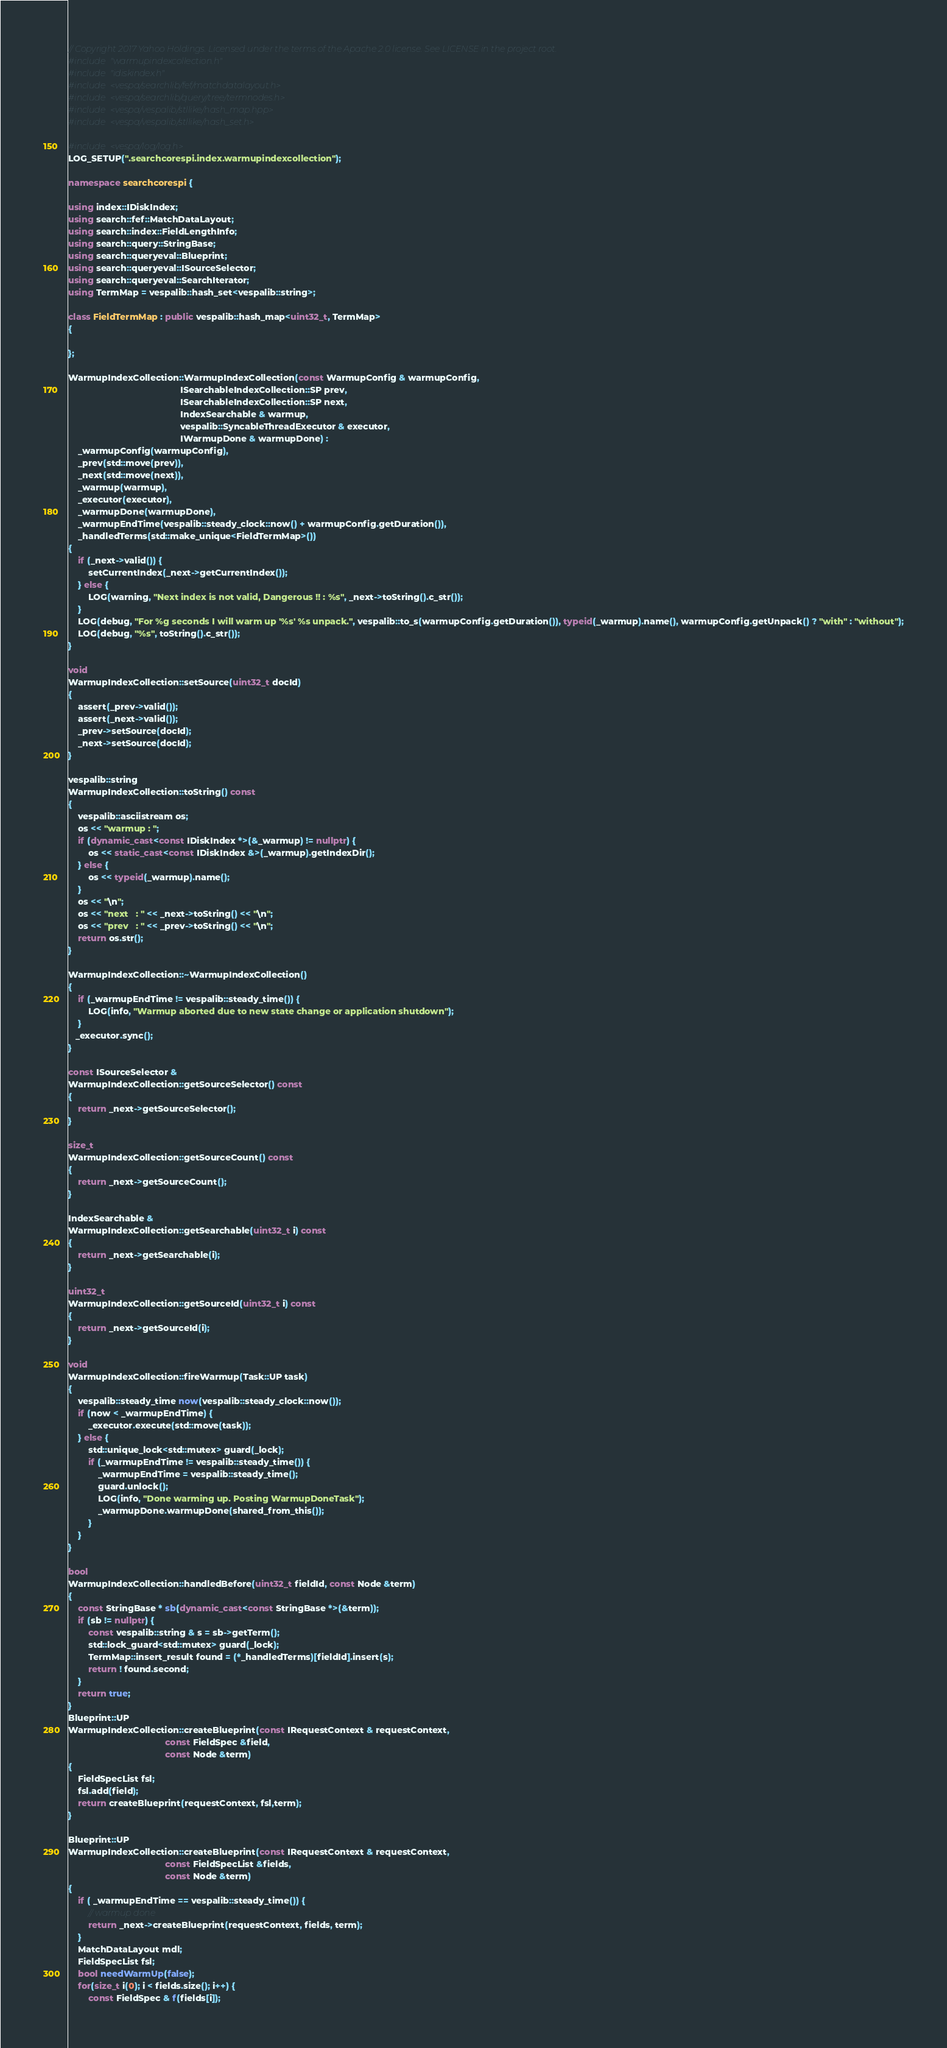Convert code to text. <code><loc_0><loc_0><loc_500><loc_500><_C++_>// Copyright 2017 Yahoo Holdings. Licensed under the terms of the Apache 2.0 license. See LICENSE in the project root.
#include "warmupindexcollection.h"
#include "idiskindex.h"
#include <vespa/searchlib/fef/matchdatalayout.h>
#include <vespa/searchlib/query/tree/termnodes.h>
#include <vespa/vespalib/stllike/hash_map.hpp>
#include <vespa/vespalib/stllike/hash_set.h>

#include <vespa/log/log.h>
LOG_SETUP(".searchcorespi.index.warmupindexcollection");

namespace searchcorespi {

using index::IDiskIndex;
using search::fef::MatchDataLayout;
using search::index::FieldLengthInfo;
using search::query::StringBase;
using search::queryeval::Blueprint;
using search::queryeval::ISourceSelector;
using search::queryeval::SearchIterator;
using TermMap = vespalib::hash_set<vespalib::string>;

class FieldTermMap : public vespalib::hash_map<uint32_t, TermMap>
{

};

WarmupIndexCollection::WarmupIndexCollection(const WarmupConfig & warmupConfig,
                                             ISearchableIndexCollection::SP prev,
                                             ISearchableIndexCollection::SP next,
                                             IndexSearchable & warmup,
                                             vespalib::SyncableThreadExecutor & executor,
                                             IWarmupDone & warmupDone) :
    _warmupConfig(warmupConfig),
    _prev(std::move(prev)),
    _next(std::move(next)),
    _warmup(warmup),
    _executor(executor),
    _warmupDone(warmupDone),
    _warmupEndTime(vespalib::steady_clock::now() + warmupConfig.getDuration()),
    _handledTerms(std::make_unique<FieldTermMap>())
{
    if (_next->valid()) {
        setCurrentIndex(_next->getCurrentIndex());
    } else {
        LOG(warning, "Next index is not valid, Dangerous !! : %s", _next->toString().c_str());
    }
    LOG(debug, "For %g seconds I will warm up '%s' %s unpack.", vespalib::to_s(warmupConfig.getDuration()), typeid(_warmup).name(), warmupConfig.getUnpack() ? "with" : "without");
    LOG(debug, "%s", toString().c_str());
}

void
WarmupIndexCollection::setSource(uint32_t docId)
{
    assert(_prev->valid());
    assert(_next->valid());
    _prev->setSource(docId);
    _next->setSource(docId);
}

vespalib::string
WarmupIndexCollection::toString() const
{
    vespalib::asciistream os;
    os << "warmup : ";
    if (dynamic_cast<const IDiskIndex *>(&_warmup) != nullptr) {
        os << static_cast<const IDiskIndex &>(_warmup).getIndexDir();
    } else {
        os << typeid(_warmup).name();
    }
    os << "\n";
    os << "next   : " << _next->toString() << "\n";
    os << "prev   : " << _prev->toString() << "\n";
    return os.str();
}

WarmupIndexCollection::~WarmupIndexCollection()
{
    if (_warmupEndTime != vespalib::steady_time()) {
        LOG(info, "Warmup aborted due to new state change or application shutdown");
    }
   _executor.sync();
}

const ISourceSelector &
WarmupIndexCollection::getSourceSelector() const
{
    return _next->getSourceSelector();
}

size_t
WarmupIndexCollection::getSourceCount() const
{
    return _next->getSourceCount();
}

IndexSearchable &
WarmupIndexCollection::getSearchable(uint32_t i) const
{
    return _next->getSearchable(i);
}

uint32_t
WarmupIndexCollection::getSourceId(uint32_t i) const
{
    return _next->getSourceId(i);
}

void
WarmupIndexCollection::fireWarmup(Task::UP task)
{
    vespalib::steady_time now(vespalib::steady_clock::now());
    if (now < _warmupEndTime) {
        _executor.execute(std::move(task));
    } else {
        std::unique_lock<std::mutex> guard(_lock);
        if (_warmupEndTime != vespalib::steady_time()) {
            _warmupEndTime = vespalib::steady_time();
            guard.unlock();
            LOG(info, "Done warming up. Posting WarmupDoneTask");
            _warmupDone.warmupDone(shared_from_this());
        }
    }
}

bool
WarmupIndexCollection::handledBefore(uint32_t fieldId, const Node &term)
{
    const StringBase * sb(dynamic_cast<const StringBase *>(&term));
    if (sb != nullptr) {
        const vespalib::string & s = sb->getTerm();
        std::lock_guard<std::mutex> guard(_lock);
        TermMap::insert_result found = (*_handledTerms)[fieldId].insert(s);
        return ! found.second;
    }
    return true;
}
Blueprint::UP
WarmupIndexCollection::createBlueprint(const IRequestContext & requestContext,
                                       const FieldSpec &field,
                                       const Node &term)
{
    FieldSpecList fsl;
    fsl.add(field);
    return createBlueprint(requestContext, fsl,term);
}

Blueprint::UP
WarmupIndexCollection::createBlueprint(const IRequestContext & requestContext,
                                       const FieldSpecList &fields,
                                       const Node &term)
{
    if ( _warmupEndTime == vespalib::steady_time()) {
        // warmup done
        return _next->createBlueprint(requestContext, fields, term);
    }
    MatchDataLayout mdl;
    FieldSpecList fsl;
    bool needWarmUp(false);
    for(size_t i(0); i < fields.size(); i++) {
        const FieldSpec & f(fields[i]);</code> 